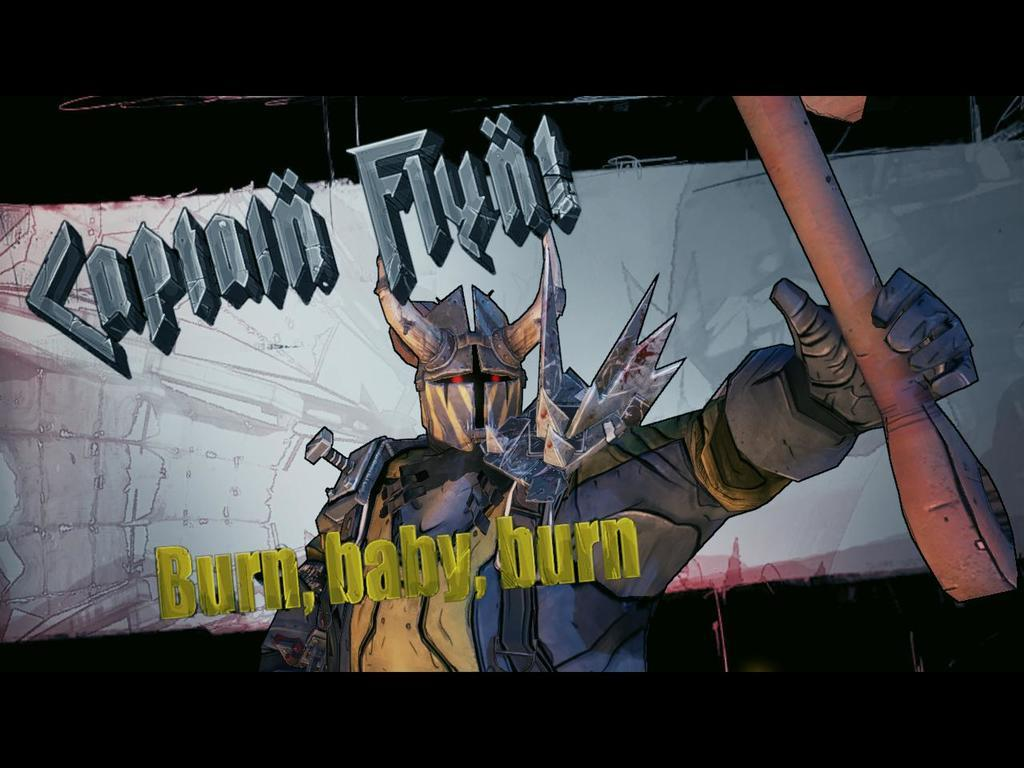What type of image is being described? The image is animated. Are there any words or letters in the image? Yes, there is text in the image. Can you describe the character in the image? There is a stranger in the image. What is the stranger holding? The stranger is holding an object. What type of mint is being used to flavor the liquid in the image? There is no mint or liquid present in the image; it features an animated scene with text and a stranger holding an object. 